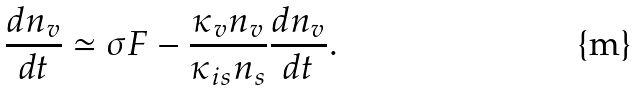Convert formula to latex. <formula><loc_0><loc_0><loc_500><loc_500>\frac { d n _ { v } } { d t } \simeq \sigma F - \frac { \kappa _ { v } n _ { v } } { \kappa _ { i s } n _ { s } } \frac { d n _ { v } } { d t } .</formula> 